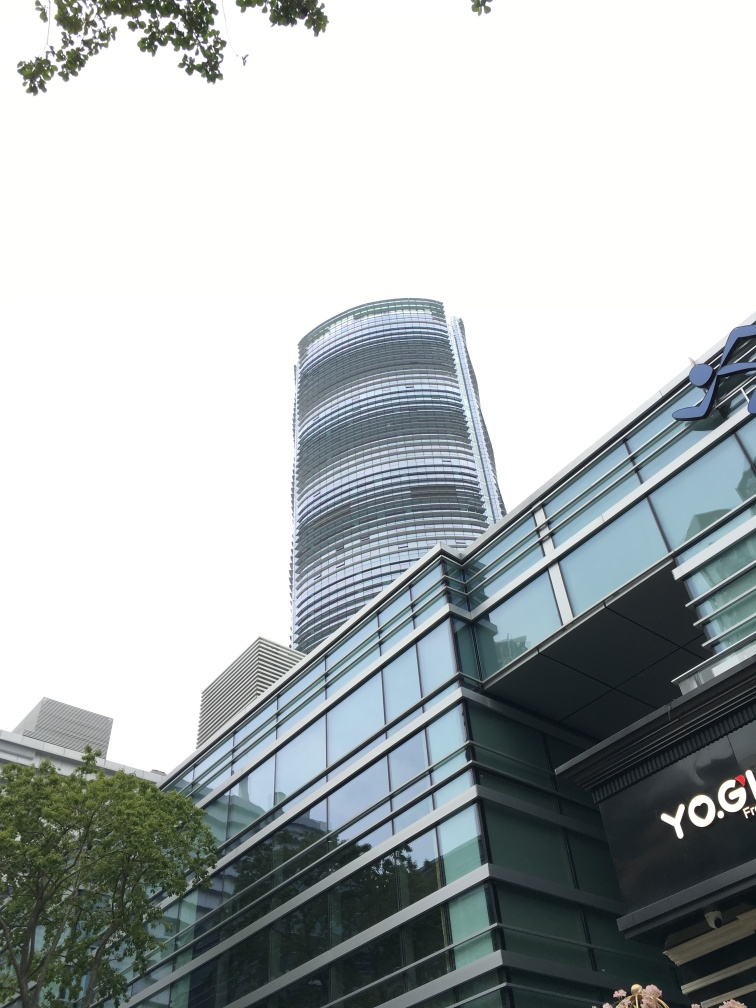What time of day does this photo seem to be taken? Given the cool and diffused quality of light and the lack of strong shadows, it appears that the photo may have been taken either in the morning or late afternoon. However, the specific time is difficult to ascertain without observable shadows or a view of the sun's position in the sky. 